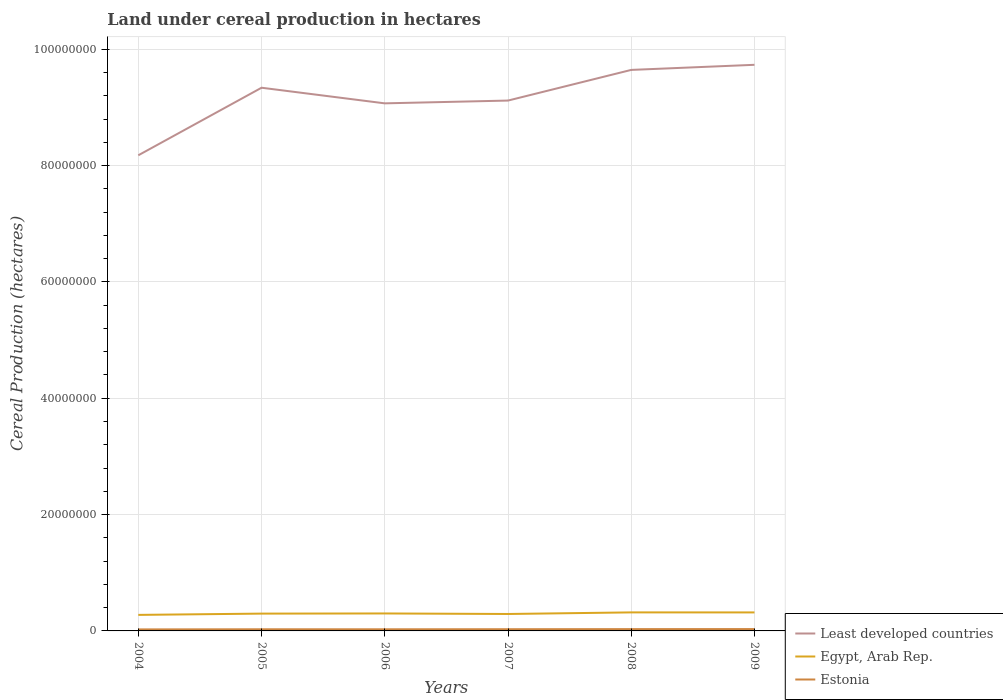Does the line corresponding to Estonia intersect with the line corresponding to Egypt, Arab Rep.?
Offer a terse response. No. Is the number of lines equal to the number of legend labels?
Ensure brevity in your answer.  Yes. Across all years, what is the maximum land under cereal production in Egypt, Arab Rep.?
Keep it short and to the point. 2.76e+06. In which year was the land under cereal production in Estonia maximum?
Your answer should be compact. 2004. What is the total land under cereal production in Estonia in the graph?
Keep it short and to the point. -3.13e+04. What is the difference between the highest and the second highest land under cereal production in Egypt, Arab Rep.?
Offer a very short reply. 4.30e+05. Is the land under cereal production in Least developed countries strictly greater than the land under cereal production in Estonia over the years?
Provide a succinct answer. No. How many years are there in the graph?
Offer a terse response. 6. What is the difference between two consecutive major ticks on the Y-axis?
Your answer should be very brief. 2.00e+07. Does the graph contain grids?
Give a very brief answer. Yes. Where does the legend appear in the graph?
Keep it short and to the point. Bottom right. What is the title of the graph?
Your response must be concise. Land under cereal production in hectares. What is the label or title of the Y-axis?
Your answer should be very brief. Cereal Production (hectares). What is the Cereal Production (hectares) in Least developed countries in 2004?
Make the answer very short. 8.18e+07. What is the Cereal Production (hectares) of Egypt, Arab Rep. in 2004?
Ensure brevity in your answer.  2.76e+06. What is the Cereal Production (hectares) of Estonia in 2004?
Provide a short and direct response. 2.61e+05. What is the Cereal Production (hectares) of Least developed countries in 2005?
Your answer should be compact. 9.34e+07. What is the Cereal Production (hectares) in Egypt, Arab Rep. in 2005?
Offer a terse response. 2.98e+06. What is the Cereal Production (hectares) in Estonia in 2005?
Provide a short and direct response. 2.82e+05. What is the Cereal Production (hectares) of Least developed countries in 2006?
Your answer should be very brief. 9.07e+07. What is the Cereal Production (hectares) in Egypt, Arab Rep. in 2006?
Provide a succinct answer. 3.00e+06. What is the Cereal Production (hectares) of Estonia in 2006?
Provide a succinct answer. 2.80e+05. What is the Cereal Production (hectares) of Least developed countries in 2007?
Your answer should be very brief. 9.12e+07. What is the Cereal Production (hectares) of Egypt, Arab Rep. in 2007?
Make the answer very short. 2.91e+06. What is the Cereal Production (hectares) in Estonia in 2007?
Ensure brevity in your answer.  2.92e+05. What is the Cereal Production (hectares) in Least developed countries in 2008?
Make the answer very short. 9.64e+07. What is the Cereal Production (hectares) of Egypt, Arab Rep. in 2008?
Keep it short and to the point. 3.19e+06. What is the Cereal Production (hectares) of Estonia in 2008?
Provide a short and direct response. 3.09e+05. What is the Cereal Production (hectares) of Least developed countries in 2009?
Your answer should be compact. 9.73e+07. What is the Cereal Production (hectares) in Egypt, Arab Rep. in 2009?
Provide a succinct answer. 3.18e+06. What is the Cereal Production (hectares) in Estonia in 2009?
Provide a short and direct response. 3.16e+05. Across all years, what is the maximum Cereal Production (hectares) in Least developed countries?
Your response must be concise. 9.73e+07. Across all years, what is the maximum Cereal Production (hectares) of Egypt, Arab Rep.?
Your response must be concise. 3.19e+06. Across all years, what is the maximum Cereal Production (hectares) of Estonia?
Ensure brevity in your answer.  3.16e+05. Across all years, what is the minimum Cereal Production (hectares) of Least developed countries?
Keep it short and to the point. 8.18e+07. Across all years, what is the minimum Cereal Production (hectares) of Egypt, Arab Rep.?
Give a very brief answer. 2.76e+06. Across all years, what is the minimum Cereal Production (hectares) of Estonia?
Offer a very short reply. 2.61e+05. What is the total Cereal Production (hectares) of Least developed countries in the graph?
Offer a terse response. 5.51e+08. What is the total Cereal Production (hectares) of Egypt, Arab Rep. in the graph?
Ensure brevity in your answer.  1.80e+07. What is the total Cereal Production (hectares) in Estonia in the graph?
Make the answer very short. 1.74e+06. What is the difference between the Cereal Production (hectares) in Least developed countries in 2004 and that in 2005?
Provide a short and direct response. -1.16e+07. What is the difference between the Cereal Production (hectares) in Egypt, Arab Rep. in 2004 and that in 2005?
Provide a short and direct response. -2.19e+05. What is the difference between the Cereal Production (hectares) of Estonia in 2004 and that in 2005?
Give a very brief answer. -2.11e+04. What is the difference between the Cereal Production (hectares) of Least developed countries in 2004 and that in 2006?
Provide a succinct answer. -8.93e+06. What is the difference between the Cereal Production (hectares) of Egypt, Arab Rep. in 2004 and that in 2006?
Make the answer very short. -2.47e+05. What is the difference between the Cereal Production (hectares) in Estonia in 2004 and that in 2006?
Your answer should be compact. -1.93e+04. What is the difference between the Cereal Production (hectares) of Least developed countries in 2004 and that in 2007?
Your answer should be compact. -9.41e+06. What is the difference between the Cereal Production (hectares) in Egypt, Arab Rep. in 2004 and that in 2007?
Keep it short and to the point. -1.56e+05. What is the difference between the Cereal Production (hectares) in Estonia in 2004 and that in 2007?
Keep it short and to the point. -3.13e+04. What is the difference between the Cereal Production (hectares) in Least developed countries in 2004 and that in 2008?
Your answer should be very brief. -1.47e+07. What is the difference between the Cereal Production (hectares) in Egypt, Arab Rep. in 2004 and that in 2008?
Your response must be concise. -4.30e+05. What is the difference between the Cereal Production (hectares) of Estonia in 2004 and that in 2008?
Give a very brief answer. -4.83e+04. What is the difference between the Cereal Production (hectares) in Least developed countries in 2004 and that in 2009?
Your answer should be compact. -1.56e+07. What is the difference between the Cereal Production (hectares) in Egypt, Arab Rep. in 2004 and that in 2009?
Keep it short and to the point. -4.23e+05. What is the difference between the Cereal Production (hectares) of Estonia in 2004 and that in 2009?
Offer a very short reply. -5.54e+04. What is the difference between the Cereal Production (hectares) in Least developed countries in 2005 and that in 2006?
Offer a very short reply. 2.68e+06. What is the difference between the Cereal Production (hectares) in Egypt, Arab Rep. in 2005 and that in 2006?
Provide a short and direct response. -2.72e+04. What is the difference between the Cereal Production (hectares) in Estonia in 2005 and that in 2006?
Your answer should be very brief. 1859. What is the difference between the Cereal Production (hectares) of Least developed countries in 2005 and that in 2007?
Provide a succinct answer. 2.21e+06. What is the difference between the Cereal Production (hectares) of Egypt, Arab Rep. in 2005 and that in 2007?
Provide a short and direct response. 6.36e+04. What is the difference between the Cereal Production (hectares) of Estonia in 2005 and that in 2007?
Make the answer very short. -1.01e+04. What is the difference between the Cereal Production (hectares) of Least developed countries in 2005 and that in 2008?
Your response must be concise. -3.07e+06. What is the difference between the Cereal Production (hectares) in Egypt, Arab Rep. in 2005 and that in 2008?
Give a very brief answer. -2.11e+05. What is the difference between the Cereal Production (hectares) in Estonia in 2005 and that in 2008?
Your response must be concise. -2.72e+04. What is the difference between the Cereal Production (hectares) of Least developed countries in 2005 and that in 2009?
Your answer should be compact. -3.94e+06. What is the difference between the Cereal Production (hectares) in Egypt, Arab Rep. in 2005 and that in 2009?
Keep it short and to the point. -2.04e+05. What is the difference between the Cereal Production (hectares) in Estonia in 2005 and that in 2009?
Make the answer very short. -3.43e+04. What is the difference between the Cereal Production (hectares) of Least developed countries in 2006 and that in 2007?
Give a very brief answer. -4.77e+05. What is the difference between the Cereal Production (hectares) of Egypt, Arab Rep. in 2006 and that in 2007?
Offer a terse response. 9.08e+04. What is the difference between the Cereal Production (hectares) of Estonia in 2006 and that in 2007?
Make the answer very short. -1.20e+04. What is the difference between the Cereal Production (hectares) in Least developed countries in 2006 and that in 2008?
Offer a very short reply. -5.75e+06. What is the difference between the Cereal Production (hectares) of Egypt, Arab Rep. in 2006 and that in 2008?
Ensure brevity in your answer.  -1.84e+05. What is the difference between the Cereal Production (hectares) in Estonia in 2006 and that in 2008?
Your answer should be compact. -2.91e+04. What is the difference between the Cereal Production (hectares) of Least developed countries in 2006 and that in 2009?
Ensure brevity in your answer.  -6.63e+06. What is the difference between the Cereal Production (hectares) in Egypt, Arab Rep. in 2006 and that in 2009?
Offer a terse response. -1.77e+05. What is the difference between the Cereal Production (hectares) of Estonia in 2006 and that in 2009?
Your response must be concise. -3.62e+04. What is the difference between the Cereal Production (hectares) of Least developed countries in 2007 and that in 2008?
Keep it short and to the point. -5.27e+06. What is the difference between the Cereal Production (hectares) of Egypt, Arab Rep. in 2007 and that in 2008?
Provide a short and direct response. -2.74e+05. What is the difference between the Cereal Production (hectares) of Estonia in 2007 and that in 2008?
Ensure brevity in your answer.  -1.71e+04. What is the difference between the Cereal Production (hectares) of Least developed countries in 2007 and that in 2009?
Give a very brief answer. -6.15e+06. What is the difference between the Cereal Production (hectares) in Egypt, Arab Rep. in 2007 and that in 2009?
Your answer should be very brief. -2.68e+05. What is the difference between the Cereal Production (hectares) of Estonia in 2007 and that in 2009?
Ensure brevity in your answer.  -2.42e+04. What is the difference between the Cereal Production (hectares) of Least developed countries in 2008 and that in 2009?
Ensure brevity in your answer.  -8.76e+05. What is the difference between the Cereal Production (hectares) in Egypt, Arab Rep. in 2008 and that in 2009?
Offer a very short reply. 6956. What is the difference between the Cereal Production (hectares) of Estonia in 2008 and that in 2009?
Your answer should be very brief. -7113. What is the difference between the Cereal Production (hectares) in Least developed countries in 2004 and the Cereal Production (hectares) in Egypt, Arab Rep. in 2005?
Your answer should be compact. 7.88e+07. What is the difference between the Cereal Production (hectares) of Least developed countries in 2004 and the Cereal Production (hectares) of Estonia in 2005?
Offer a terse response. 8.15e+07. What is the difference between the Cereal Production (hectares) in Egypt, Arab Rep. in 2004 and the Cereal Production (hectares) in Estonia in 2005?
Give a very brief answer. 2.47e+06. What is the difference between the Cereal Production (hectares) in Least developed countries in 2004 and the Cereal Production (hectares) in Egypt, Arab Rep. in 2006?
Your answer should be compact. 7.88e+07. What is the difference between the Cereal Production (hectares) of Least developed countries in 2004 and the Cereal Production (hectares) of Estonia in 2006?
Offer a terse response. 8.15e+07. What is the difference between the Cereal Production (hectares) of Egypt, Arab Rep. in 2004 and the Cereal Production (hectares) of Estonia in 2006?
Make the answer very short. 2.48e+06. What is the difference between the Cereal Production (hectares) in Least developed countries in 2004 and the Cereal Production (hectares) in Egypt, Arab Rep. in 2007?
Offer a terse response. 7.89e+07. What is the difference between the Cereal Production (hectares) of Least developed countries in 2004 and the Cereal Production (hectares) of Estonia in 2007?
Your answer should be very brief. 8.15e+07. What is the difference between the Cereal Production (hectares) in Egypt, Arab Rep. in 2004 and the Cereal Production (hectares) in Estonia in 2007?
Ensure brevity in your answer.  2.46e+06. What is the difference between the Cereal Production (hectares) of Least developed countries in 2004 and the Cereal Production (hectares) of Egypt, Arab Rep. in 2008?
Keep it short and to the point. 7.86e+07. What is the difference between the Cereal Production (hectares) of Least developed countries in 2004 and the Cereal Production (hectares) of Estonia in 2008?
Your response must be concise. 8.15e+07. What is the difference between the Cereal Production (hectares) in Egypt, Arab Rep. in 2004 and the Cereal Production (hectares) in Estonia in 2008?
Provide a short and direct response. 2.45e+06. What is the difference between the Cereal Production (hectares) in Least developed countries in 2004 and the Cereal Production (hectares) in Egypt, Arab Rep. in 2009?
Keep it short and to the point. 7.86e+07. What is the difference between the Cereal Production (hectares) of Least developed countries in 2004 and the Cereal Production (hectares) of Estonia in 2009?
Provide a short and direct response. 8.14e+07. What is the difference between the Cereal Production (hectares) in Egypt, Arab Rep. in 2004 and the Cereal Production (hectares) in Estonia in 2009?
Give a very brief answer. 2.44e+06. What is the difference between the Cereal Production (hectares) of Least developed countries in 2005 and the Cereal Production (hectares) of Egypt, Arab Rep. in 2006?
Give a very brief answer. 9.04e+07. What is the difference between the Cereal Production (hectares) in Least developed countries in 2005 and the Cereal Production (hectares) in Estonia in 2006?
Offer a very short reply. 9.31e+07. What is the difference between the Cereal Production (hectares) of Egypt, Arab Rep. in 2005 and the Cereal Production (hectares) of Estonia in 2006?
Provide a succinct answer. 2.69e+06. What is the difference between the Cereal Production (hectares) of Least developed countries in 2005 and the Cereal Production (hectares) of Egypt, Arab Rep. in 2007?
Provide a short and direct response. 9.05e+07. What is the difference between the Cereal Production (hectares) of Least developed countries in 2005 and the Cereal Production (hectares) of Estonia in 2007?
Ensure brevity in your answer.  9.31e+07. What is the difference between the Cereal Production (hectares) of Egypt, Arab Rep. in 2005 and the Cereal Production (hectares) of Estonia in 2007?
Provide a succinct answer. 2.68e+06. What is the difference between the Cereal Production (hectares) in Least developed countries in 2005 and the Cereal Production (hectares) in Egypt, Arab Rep. in 2008?
Offer a terse response. 9.02e+07. What is the difference between the Cereal Production (hectares) in Least developed countries in 2005 and the Cereal Production (hectares) in Estonia in 2008?
Keep it short and to the point. 9.31e+07. What is the difference between the Cereal Production (hectares) in Egypt, Arab Rep. in 2005 and the Cereal Production (hectares) in Estonia in 2008?
Offer a very short reply. 2.67e+06. What is the difference between the Cereal Production (hectares) in Least developed countries in 2005 and the Cereal Production (hectares) in Egypt, Arab Rep. in 2009?
Ensure brevity in your answer.  9.02e+07. What is the difference between the Cereal Production (hectares) of Least developed countries in 2005 and the Cereal Production (hectares) of Estonia in 2009?
Provide a succinct answer. 9.31e+07. What is the difference between the Cereal Production (hectares) in Egypt, Arab Rep. in 2005 and the Cereal Production (hectares) in Estonia in 2009?
Ensure brevity in your answer.  2.66e+06. What is the difference between the Cereal Production (hectares) of Least developed countries in 2006 and the Cereal Production (hectares) of Egypt, Arab Rep. in 2007?
Ensure brevity in your answer.  8.78e+07. What is the difference between the Cereal Production (hectares) in Least developed countries in 2006 and the Cereal Production (hectares) in Estonia in 2007?
Your answer should be compact. 9.04e+07. What is the difference between the Cereal Production (hectares) in Egypt, Arab Rep. in 2006 and the Cereal Production (hectares) in Estonia in 2007?
Make the answer very short. 2.71e+06. What is the difference between the Cereal Production (hectares) of Least developed countries in 2006 and the Cereal Production (hectares) of Egypt, Arab Rep. in 2008?
Ensure brevity in your answer.  8.75e+07. What is the difference between the Cereal Production (hectares) of Least developed countries in 2006 and the Cereal Production (hectares) of Estonia in 2008?
Provide a short and direct response. 9.04e+07. What is the difference between the Cereal Production (hectares) of Egypt, Arab Rep. in 2006 and the Cereal Production (hectares) of Estonia in 2008?
Your answer should be compact. 2.69e+06. What is the difference between the Cereal Production (hectares) in Least developed countries in 2006 and the Cereal Production (hectares) in Egypt, Arab Rep. in 2009?
Make the answer very short. 8.75e+07. What is the difference between the Cereal Production (hectares) in Least developed countries in 2006 and the Cereal Production (hectares) in Estonia in 2009?
Offer a terse response. 9.04e+07. What is the difference between the Cereal Production (hectares) in Egypt, Arab Rep. in 2006 and the Cereal Production (hectares) in Estonia in 2009?
Your response must be concise. 2.69e+06. What is the difference between the Cereal Production (hectares) of Least developed countries in 2007 and the Cereal Production (hectares) of Egypt, Arab Rep. in 2008?
Offer a very short reply. 8.80e+07. What is the difference between the Cereal Production (hectares) in Least developed countries in 2007 and the Cereal Production (hectares) in Estonia in 2008?
Offer a very short reply. 9.09e+07. What is the difference between the Cereal Production (hectares) in Egypt, Arab Rep. in 2007 and the Cereal Production (hectares) in Estonia in 2008?
Your answer should be compact. 2.60e+06. What is the difference between the Cereal Production (hectares) of Least developed countries in 2007 and the Cereal Production (hectares) of Egypt, Arab Rep. in 2009?
Your answer should be compact. 8.80e+07. What is the difference between the Cereal Production (hectares) of Least developed countries in 2007 and the Cereal Production (hectares) of Estonia in 2009?
Your answer should be compact. 9.09e+07. What is the difference between the Cereal Production (hectares) in Egypt, Arab Rep. in 2007 and the Cereal Production (hectares) in Estonia in 2009?
Keep it short and to the point. 2.60e+06. What is the difference between the Cereal Production (hectares) in Least developed countries in 2008 and the Cereal Production (hectares) in Egypt, Arab Rep. in 2009?
Offer a very short reply. 9.33e+07. What is the difference between the Cereal Production (hectares) in Least developed countries in 2008 and the Cereal Production (hectares) in Estonia in 2009?
Your answer should be compact. 9.61e+07. What is the difference between the Cereal Production (hectares) of Egypt, Arab Rep. in 2008 and the Cereal Production (hectares) of Estonia in 2009?
Your response must be concise. 2.87e+06. What is the average Cereal Production (hectares) of Least developed countries per year?
Provide a succinct answer. 9.18e+07. What is the average Cereal Production (hectares) of Egypt, Arab Rep. per year?
Your answer should be compact. 3.00e+06. What is the average Cereal Production (hectares) in Estonia per year?
Provide a succinct answer. 2.90e+05. In the year 2004, what is the difference between the Cereal Production (hectares) of Least developed countries and Cereal Production (hectares) of Egypt, Arab Rep.?
Offer a terse response. 7.90e+07. In the year 2004, what is the difference between the Cereal Production (hectares) in Least developed countries and Cereal Production (hectares) in Estonia?
Offer a very short reply. 8.15e+07. In the year 2004, what is the difference between the Cereal Production (hectares) in Egypt, Arab Rep. and Cereal Production (hectares) in Estonia?
Your answer should be very brief. 2.49e+06. In the year 2005, what is the difference between the Cereal Production (hectares) of Least developed countries and Cereal Production (hectares) of Egypt, Arab Rep.?
Make the answer very short. 9.04e+07. In the year 2005, what is the difference between the Cereal Production (hectares) of Least developed countries and Cereal Production (hectares) of Estonia?
Provide a short and direct response. 9.31e+07. In the year 2005, what is the difference between the Cereal Production (hectares) of Egypt, Arab Rep. and Cereal Production (hectares) of Estonia?
Make the answer very short. 2.69e+06. In the year 2006, what is the difference between the Cereal Production (hectares) in Least developed countries and Cereal Production (hectares) in Egypt, Arab Rep.?
Provide a succinct answer. 8.77e+07. In the year 2006, what is the difference between the Cereal Production (hectares) of Least developed countries and Cereal Production (hectares) of Estonia?
Offer a very short reply. 9.04e+07. In the year 2006, what is the difference between the Cereal Production (hectares) of Egypt, Arab Rep. and Cereal Production (hectares) of Estonia?
Keep it short and to the point. 2.72e+06. In the year 2007, what is the difference between the Cereal Production (hectares) of Least developed countries and Cereal Production (hectares) of Egypt, Arab Rep.?
Offer a very short reply. 8.83e+07. In the year 2007, what is the difference between the Cereal Production (hectares) in Least developed countries and Cereal Production (hectares) in Estonia?
Provide a short and direct response. 9.09e+07. In the year 2007, what is the difference between the Cereal Production (hectares) of Egypt, Arab Rep. and Cereal Production (hectares) of Estonia?
Ensure brevity in your answer.  2.62e+06. In the year 2008, what is the difference between the Cereal Production (hectares) in Least developed countries and Cereal Production (hectares) in Egypt, Arab Rep.?
Provide a succinct answer. 9.33e+07. In the year 2008, what is the difference between the Cereal Production (hectares) in Least developed countries and Cereal Production (hectares) in Estonia?
Give a very brief answer. 9.61e+07. In the year 2008, what is the difference between the Cereal Production (hectares) of Egypt, Arab Rep. and Cereal Production (hectares) of Estonia?
Keep it short and to the point. 2.88e+06. In the year 2009, what is the difference between the Cereal Production (hectares) in Least developed countries and Cereal Production (hectares) in Egypt, Arab Rep.?
Your answer should be very brief. 9.41e+07. In the year 2009, what is the difference between the Cereal Production (hectares) of Least developed countries and Cereal Production (hectares) of Estonia?
Give a very brief answer. 9.70e+07. In the year 2009, what is the difference between the Cereal Production (hectares) in Egypt, Arab Rep. and Cereal Production (hectares) in Estonia?
Make the answer very short. 2.86e+06. What is the ratio of the Cereal Production (hectares) of Least developed countries in 2004 to that in 2005?
Your answer should be compact. 0.88. What is the ratio of the Cereal Production (hectares) of Egypt, Arab Rep. in 2004 to that in 2005?
Your answer should be very brief. 0.93. What is the ratio of the Cereal Production (hectares) in Estonia in 2004 to that in 2005?
Give a very brief answer. 0.93. What is the ratio of the Cereal Production (hectares) in Least developed countries in 2004 to that in 2006?
Keep it short and to the point. 0.9. What is the ratio of the Cereal Production (hectares) of Egypt, Arab Rep. in 2004 to that in 2006?
Your answer should be very brief. 0.92. What is the ratio of the Cereal Production (hectares) in Estonia in 2004 to that in 2006?
Offer a terse response. 0.93. What is the ratio of the Cereal Production (hectares) in Least developed countries in 2004 to that in 2007?
Offer a very short reply. 0.9. What is the ratio of the Cereal Production (hectares) in Egypt, Arab Rep. in 2004 to that in 2007?
Give a very brief answer. 0.95. What is the ratio of the Cereal Production (hectares) in Estonia in 2004 to that in 2007?
Offer a very short reply. 0.89. What is the ratio of the Cereal Production (hectares) of Least developed countries in 2004 to that in 2008?
Your answer should be compact. 0.85. What is the ratio of the Cereal Production (hectares) in Egypt, Arab Rep. in 2004 to that in 2008?
Offer a terse response. 0.86. What is the ratio of the Cereal Production (hectares) of Estonia in 2004 to that in 2008?
Ensure brevity in your answer.  0.84. What is the ratio of the Cereal Production (hectares) of Least developed countries in 2004 to that in 2009?
Offer a terse response. 0.84. What is the ratio of the Cereal Production (hectares) of Egypt, Arab Rep. in 2004 to that in 2009?
Offer a terse response. 0.87. What is the ratio of the Cereal Production (hectares) of Estonia in 2004 to that in 2009?
Your answer should be compact. 0.82. What is the ratio of the Cereal Production (hectares) of Least developed countries in 2005 to that in 2006?
Your answer should be very brief. 1.03. What is the ratio of the Cereal Production (hectares) of Egypt, Arab Rep. in 2005 to that in 2006?
Ensure brevity in your answer.  0.99. What is the ratio of the Cereal Production (hectares) of Estonia in 2005 to that in 2006?
Offer a terse response. 1.01. What is the ratio of the Cereal Production (hectares) in Least developed countries in 2005 to that in 2007?
Your answer should be compact. 1.02. What is the ratio of the Cereal Production (hectares) in Egypt, Arab Rep. in 2005 to that in 2007?
Offer a terse response. 1.02. What is the ratio of the Cereal Production (hectares) of Estonia in 2005 to that in 2007?
Offer a very short reply. 0.97. What is the ratio of the Cereal Production (hectares) in Least developed countries in 2005 to that in 2008?
Give a very brief answer. 0.97. What is the ratio of the Cereal Production (hectares) of Egypt, Arab Rep. in 2005 to that in 2008?
Give a very brief answer. 0.93. What is the ratio of the Cereal Production (hectares) of Estonia in 2005 to that in 2008?
Your response must be concise. 0.91. What is the ratio of the Cereal Production (hectares) of Least developed countries in 2005 to that in 2009?
Ensure brevity in your answer.  0.96. What is the ratio of the Cereal Production (hectares) of Egypt, Arab Rep. in 2005 to that in 2009?
Keep it short and to the point. 0.94. What is the ratio of the Cereal Production (hectares) of Estonia in 2005 to that in 2009?
Offer a very short reply. 0.89. What is the ratio of the Cereal Production (hectares) in Least developed countries in 2006 to that in 2007?
Make the answer very short. 0.99. What is the ratio of the Cereal Production (hectares) in Egypt, Arab Rep. in 2006 to that in 2007?
Make the answer very short. 1.03. What is the ratio of the Cereal Production (hectares) of Estonia in 2006 to that in 2007?
Provide a succinct answer. 0.96. What is the ratio of the Cereal Production (hectares) in Least developed countries in 2006 to that in 2008?
Keep it short and to the point. 0.94. What is the ratio of the Cereal Production (hectares) in Egypt, Arab Rep. in 2006 to that in 2008?
Offer a terse response. 0.94. What is the ratio of the Cereal Production (hectares) in Estonia in 2006 to that in 2008?
Your response must be concise. 0.91. What is the ratio of the Cereal Production (hectares) of Least developed countries in 2006 to that in 2009?
Offer a terse response. 0.93. What is the ratio of the Cereal Production (hectares) in Egypt, Arab Rep. in 2006 to that in 2009?
Offer a very short reply. 0.94. What is the ratio of the Cereal Production (hectares) in Estonia in 2006 to that in 2009?
Keep it short and to the point. 0.89. What is the ratio of the Cereal Production (hectares) of Least developed countries in 2007 to that in 2008?
Offer a very short reply. 0.95. What is the ratio of the Cereal Production (hectares) in Egypt, Arab Rep. in 2007 to that in 2008?
Provide a short and direct response. 0.91. What is the ratio of the Cereal Production (hectares) in Estonia in 2007 to that in 2008?
Make the answer very short. 0.94. What is the ratio of the Cereal Production (hectares) of Least developed countries in 2007 to that in 2009?
Give a very brief answer. 0.94. What is the ratio of the Cereal Production (hectares) of Egypt, Arab Rep. in 2007 to that in 2009?
Your answer should be very brief. 0.92. What is the ratio of the Cereal Production (hectares) in Estonia in 2007 to that in 2009?
Give a very brief answer. 0.92. What is the ratio of the Cereal Production (hectares) of Estonia in 2008 to that in 2009?
Give a very brief answer. 0.98. What is the difference between the highest and the second highest Cereal Production (hectares) of Least developed countries?
Your answer should be compact. 8.76e+05. What is the difference between the highest and the second highest Cereal Production (hectares) in Egypt, Arab Rep.?
Offer a very short reply. 6956. What is the difference between the highest and the second highest Cereal Production (hectares) of Estonia?
Give a very brief answer. 7113. What is the difference between the highest and the lowest Cereal Production (hectares) of Least developed countries?
Provide a short and direct response. 1.56e+07. What is the difference between the highest and the lowest Cereal Production (hectares) of Egypt, Arab Rep.?
Provide a succinct answer. 4.30e+05. What is the difference between the highest and the lowest Cereal Production (hectares) of Estonia?
Ensure brevity in your answer.  5.54e+04. 